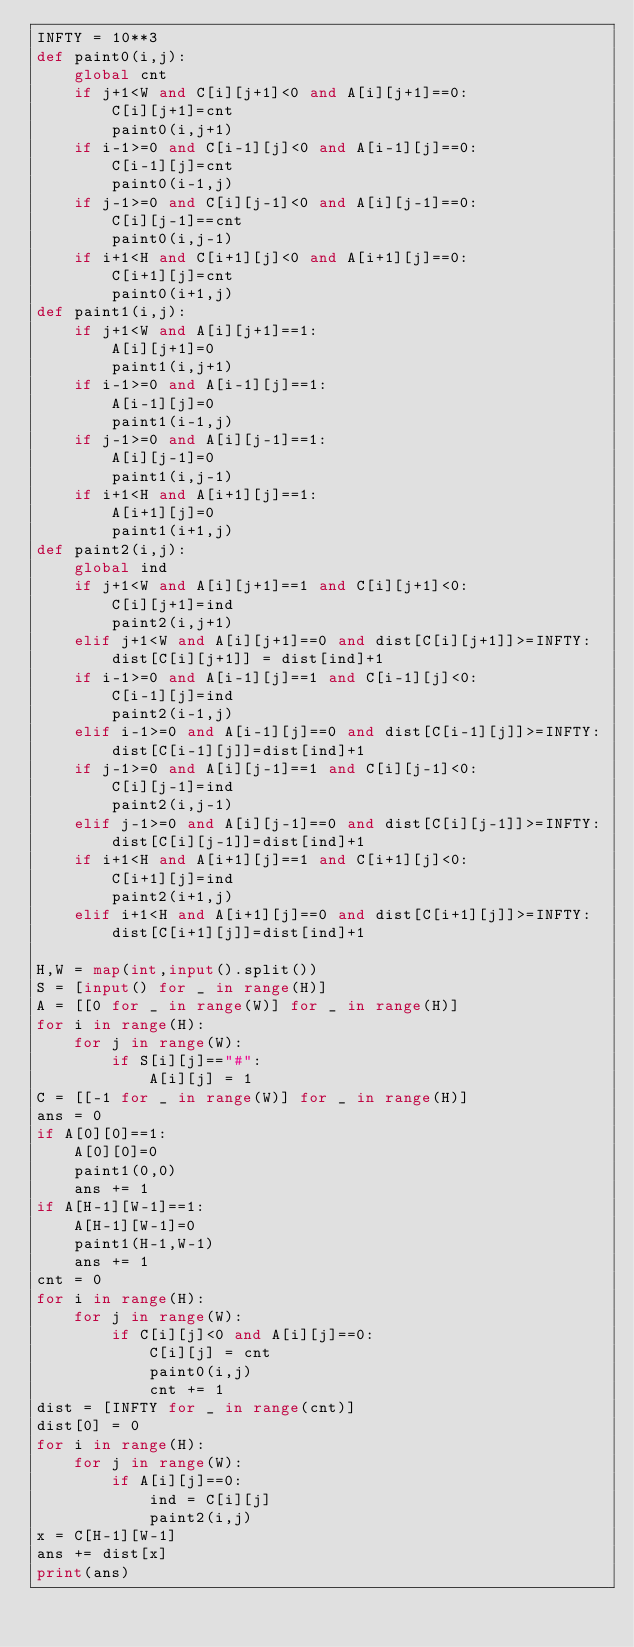Convert code to text. <code><loc_0><loc_0><loc_500><loc_500><_Python_>INFTY = 10**3
def paint0(i,j):
    global cnt
    if j+1<W and C[i][j+1]<0 and A[i][j+1]==0:
        C[i][j+1]=cnt
        paint0(i,j+1)
    if i-1>=0 and C[i-1][j]<0 and A[i-1][j]==0:
        C[i-1][j]=cnt
        paint0(i-1,j)
    if j-1>=0 and C[i][j-1]<0 and A[i][j-1]==0:
        C[i][j-1]==cnt
        paint0(i,j-1)
    if i+1<H and C[i+1][j]<0 and A[i+1][j]==0:
        C[i+1][j]=cnt
        paint0(i+1,j)
def paint1(i,j):
    if j+1<W and A[i][j+1]==1:
        A[i][j+1]=0
        paint1(i,j+1)
    if i-1>=0 and A[i-1][j]==1:
        A[i-1][j]=0
        paint1(i-1,j)
    if j-1>=0 and A[i][j-1]==1:
        A[i][j-1]=0
        paint1(i,j-1)
    if i+1<H and A[i+1][j]==1:
        A[i+1][j]=0
        paint1(i+1,j)
def paint2(i,j):
    global ind
    if j+1<W and A[i][j+1]==1 and C[i][j+1]<0:
        C[i][j+1]=ind
        paint2(i,j+1)
    elif j+1<W and A[i][j+1]==0 and dist[C[i][j+1]]>=INFTY:
        dist[C[i][j+1]] = dist[ind]+1
    if i-1>=0 and A[i-1][j]==1 and C[i-1][j]<0:
        C[i-1][j]=ind
        paint2(i-1,j)
    elif i-1>=0 and A[i-1][j]==0 and dist[C[i-1][j]]>=INFTY:
        dist[C[i-1][j]]=dist[ind]+1
    if j-1>=0 and A[i][j-1]==1 and C[i][j-1]<0:
        C[i][j-1]=ind
        paint2(i,j-1)
    elif j-1>=0 and A[i][j-1]==0 and dist[C[i][j-1]]>=INFTY:
        dist[C[i][j-1]]=dist[ind]+1
    if i+1<H and A[i+1][j]==1 and C[i+1][j]<0:
        C[i+1][j]=ind
        paint2(i+1,j)
    elif i+1<H and A[i+1][j]==0 and dist[C[i+1][j]]>=INFTY:
        dist[C[i+1][j]]=dist[ind]+1
    
H,W = map(int,input().split())
S = [input() for _ in range(H)]
A = [[0 for _ in range(W)] for _ in range(H)]
for i in range(H):
    for j in range(W):
        if S[i][j]=="#":
            A[i][j] = 1
C = [[-1 for _ in range(W)] for _ in range(H)]
ans = 0
if A[0][0]==1:
    A[0][0]=0
    paint1(0,0)
    ans += 1
if A[H-1][W-1]==1:
    A[H-1][W-1]=0
    paint1(H-1,W-1)
    ans += 1
cnt = 0
for i in range(H):
    for j in range(W):
        if C[i][j]<0 and A[i][j]==0:
            C[i][j] = cnt
            paint0(i,j)
            cnt += 1
dist = [INFTY for _ in range(cnt)]
dist[0] = 0
for i in range(H):
    for j in range(W):
        if A[i][j]==0:
            ind = C[i][j]
            paint2(i,j)
x = C[H-1][W-1]
ans += dist[x]
print(ans)</code> 